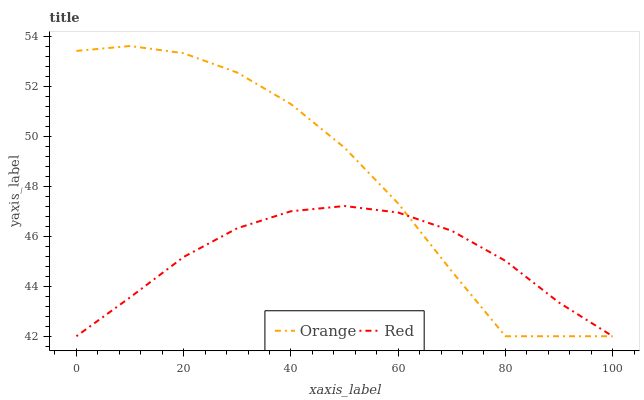Does Red have the maximum area under the curve?
Answer yes or no. No. Is Red the roughest?
Answer yes or no. No. Does Red have the highest value?
Answer yes or no. No. 